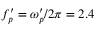<formula> <loc_0><loc_0><loc_500><loc_500>f _ { p } ^ { \prime } = \omega _ { p } ^ { \prime } / 2 \pi = 2 . 4</formula> 